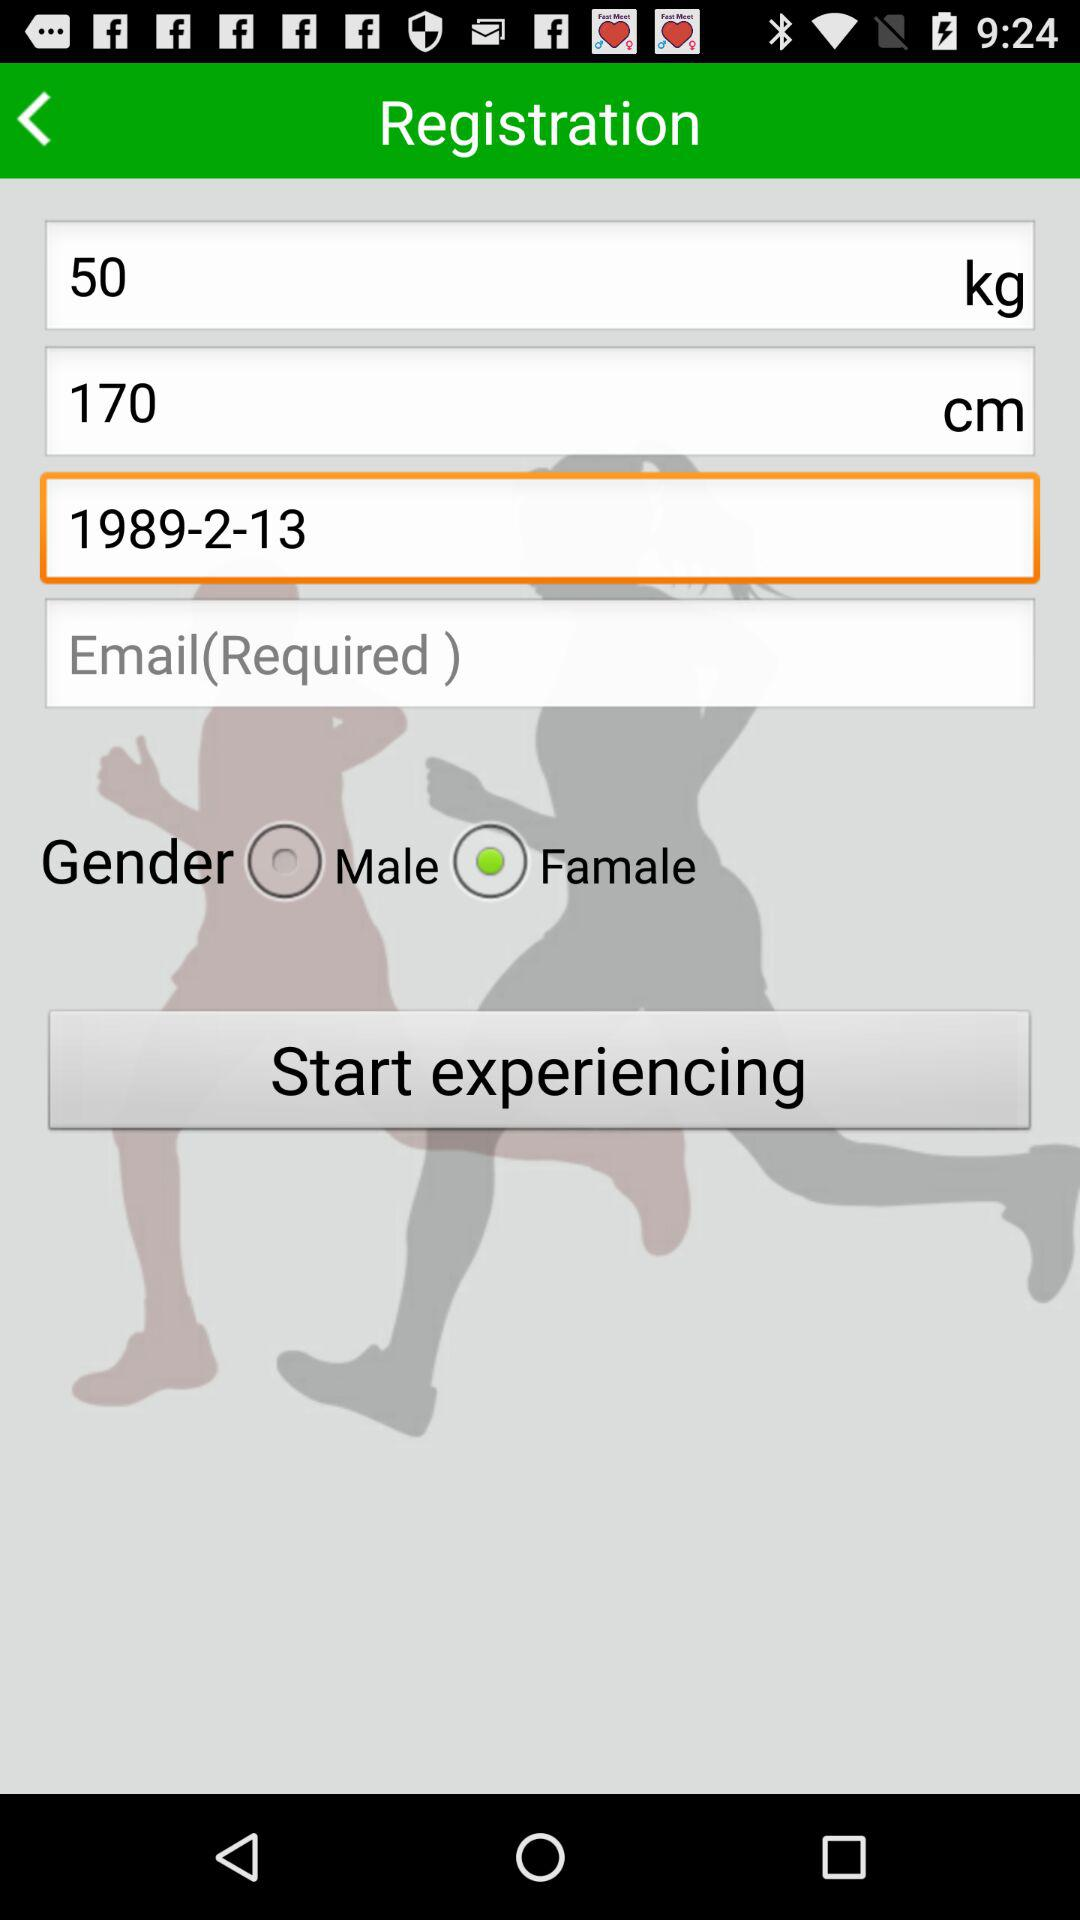What is the mentioned height? The mentioned height is 170 cm. 